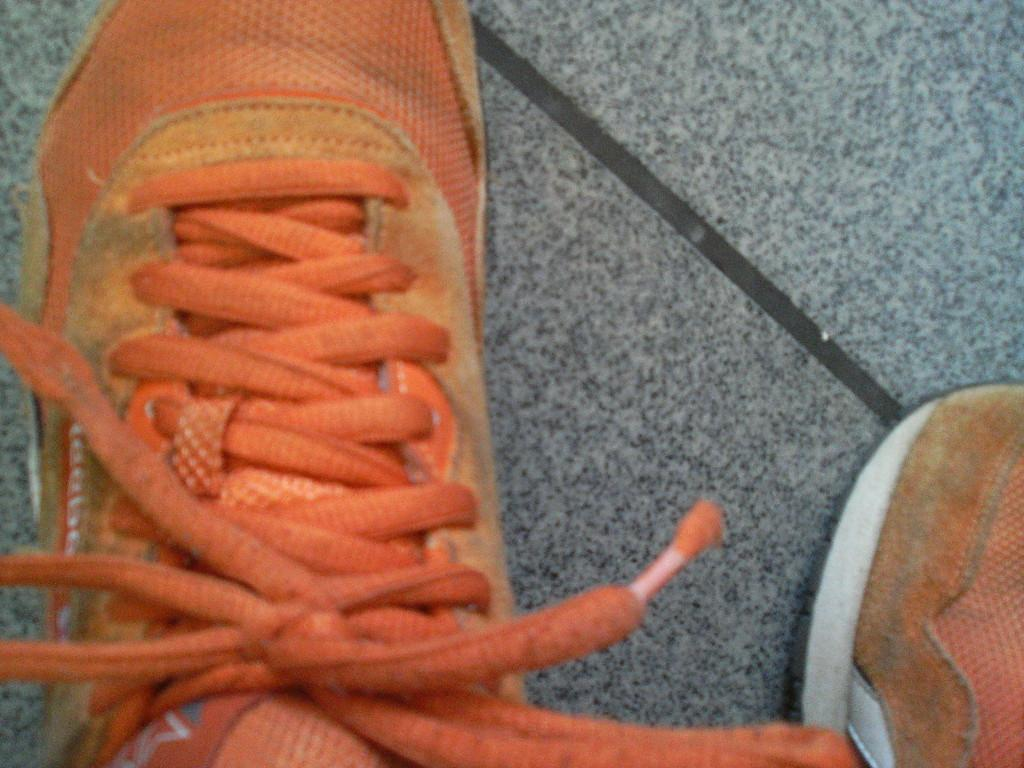What color are the shoes in the image? The shoes in the image are orange-colored. What is the color of the surface in the image? The surface in the image is grey-colored. Can you describe the behavior of the squirrel on the roof in the image? There is no squirrel or roof present in the image; it only features orange-colored shoes and a grey-colored surface. 